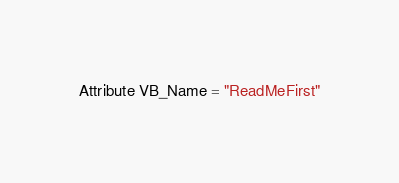Convert code to text. <code><loc_0><loc_0><loc_500><loc_500><_VisualBasic_>Attribute VB_Name = "ReadMeFirst"
</code> 